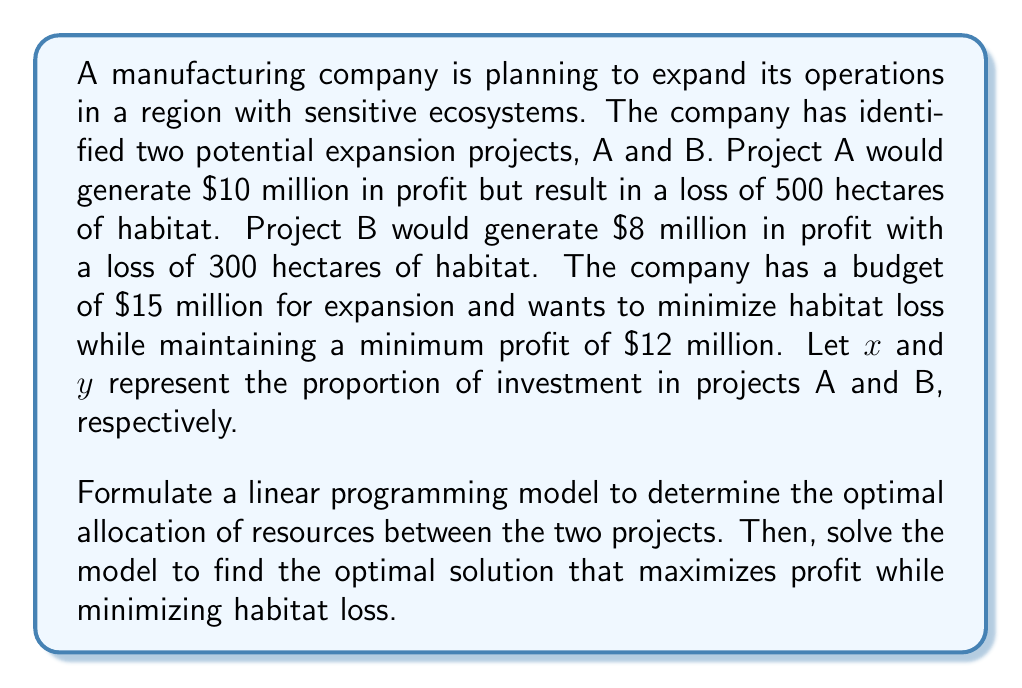Help me with this question. To formulate and solve this linear programming problem, we'll follow these steps:

1. Define the decision variables:
   $x$ = proportion of investment in Project A
   $y$ = proportion of investment in Project B

2. Formulate the objective function:
   Minimize habitat loss: $Z = 500x + 300y$

3. Define the constraints:
   a) Budget constraint: $15x + 15y \leq 15$ (simplifies to $x + y \leq 1$)
   b) Minimum profit constraint: $10x + 8y \geq 12$
   c) Non-negativity constraints: $x \geq 0, y \geq 0$

4. Set up the linear programming model:

   Minimize $Z = 500x + 300y$
   Subject to:
   $x + y \leq 1$
   $10x + 8y \geq 12$
   $x \geq 0, y \geq 0$

5. Solve the model using the graphical method:

   a) Plot the constraints:
      $x + y = 1$
      $10x + 8y = 12$

   b) Identify the feasible region

   c) Find the corner points of the feasible region:
      Point 1: (1, 0)
      Point 2: (0.8, 0.2)
      Point 3: (0, 1)

   d) Evaluate the objective function at each corner point:
      Z(1, 0) = 500
      Z(0.8, 0.2) = 460
      Z(0, 1) = 300

6. The optimal solution is the point with the minimum Z value:
   (0, 1) with Z = 300

Therefore, the optimal solution is to invest 100% in Project B.
Answer: The optimal solution is to invest 100% in Project B ($x = 0, y = 1$), resulting in a minimum habitat loss of 300 hectares while meeting the profit and budget constraints. 